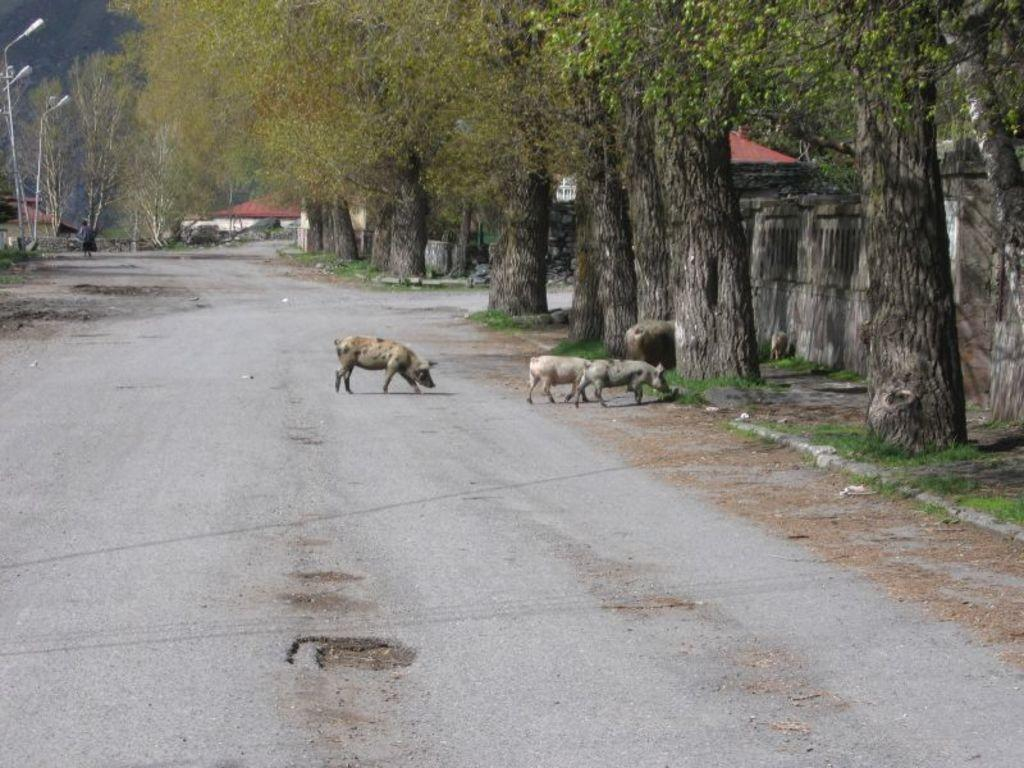What is the main feature of the image? There is a road in the image. What is present on the road? There are pigs on the road. What can be seen on the right side of the image? There is a tree on the right side of the image. What is visible in the background of the image? There are light poles and trees in the background of the image. What type of kite can be seen in the image? There is no kite present in the image. What page number is the pig on in the image? The image does not depict a book or page number; it shows pigs on a road. 